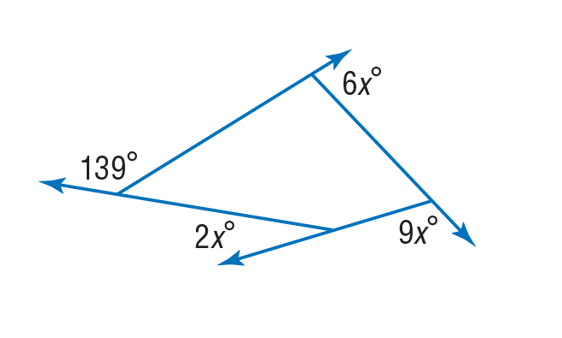Question: Find the value of x in the diagram.
Choices:
A. 13
B. 26
C. 52
D. 70
Answer with the letter. Answer: A 